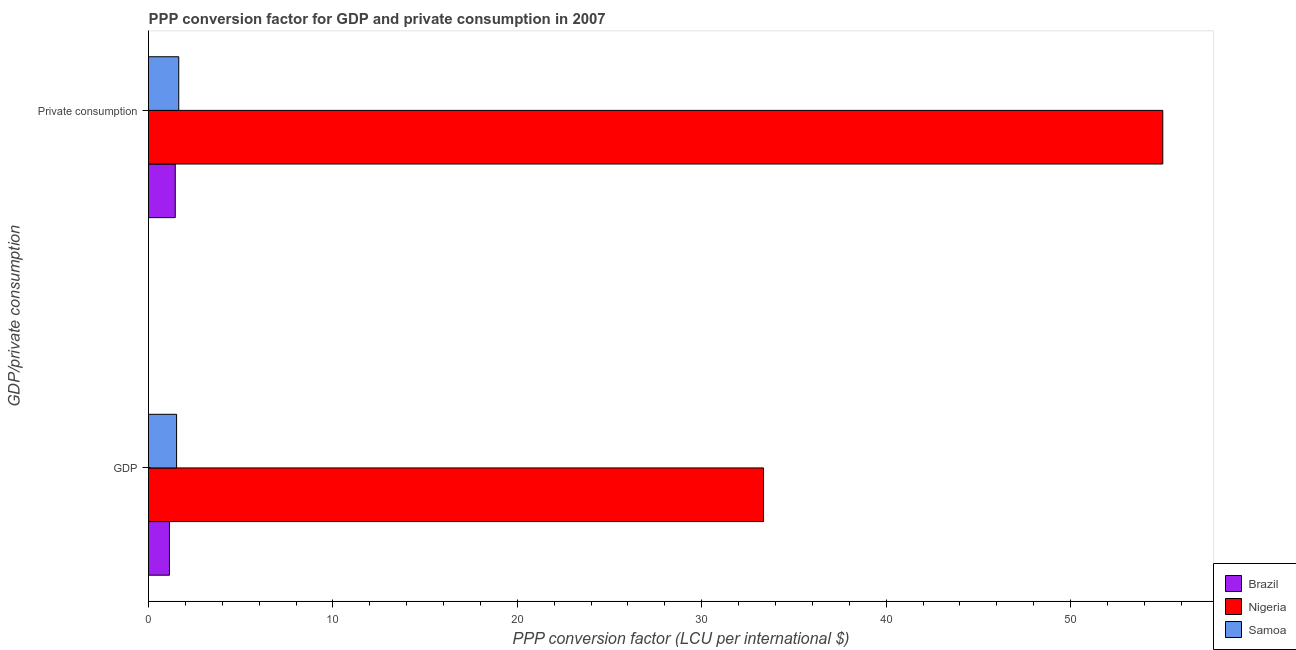How many groups of bars are there?
Keep it short and to the point. 2. Are the number of bars per tick equal to the number of legend labels?
Make the answer very short. Yes. Are the number of bars on each tick of the Y-axis equal?
Offer a very short reply. Yes. How many bars are there on the 2nd tick from the top?
Give a very brief answer. 3. How many bars are there on the 1st tick from the bottom?
Offer a terse response. 3. What is the label of the 1st group of bars from the top?
Ensure brevity in your answer.   Private consumption. What is the ppp conversion factor for gdp in Samoa?
Your response must be concise. 1.52. Across all countries, what is the maximum ppp conversion factor for private consumption?
Your response must be concise. 55. Across all countries, what is the minimum ppp conversion factor for private consumption?
Offer a terse response. 1.45. In which country was the ppp conversion factor for private consumption maximum?
Your answer should be compact. Nigeria. In which country was the ppp conversion factor for gdp minimum?
Offer a terse response. Brazil. What is the total ppp conversion factor for private consumption in the graph?
Your response must be concise. 58.09. What is the difference between the ppp conversion factor for private consumption in Samoa and that in Nigeria?
Give a very brief answer. -53.36. What is the difference between the ppp conversion factor for private consumption in Nigeria and the ppp conversion factor for gdp in Brazil?
Keep it short and to the point. 53.87. What is the average ppp conversion factor for private consumption per country?
Make the answer very short. 19.36. What is the difference between the ppp conversion factor for gdp and ppp conversion factor for private consumption in Brazil?
Provide a short and direct response. -0.31. What is the ratio of the ppp conversion factor for private consumption in Brazil to that in Nigeria?
Your answer should be compact. 0.03. Is the ppp conversion factor for gdp in Samoa less than that in Brazil?
Your response must be concise. No. What does the 3rd bar from the top in  Private consumption represents?
Offer a terse response. Brazil. What does the 2nd bar from the bottom in GDP represents?
Ensure brevity in your answer.  Nigeria. How many countries are there in the graph?
Make the answer very short. 3. How many legend labels are there?
Your answer should be very brief. 3. How are the legend labels stacked?
Offer a very short reply. Vertical. What is the title of the graph?
Offer a very short reply. PPP conversion factor for GDP and private consumption in 2007. What is the label or title of the X-axis?
Give a very brief answer. PPP conversion factor (LCU per international $). What is the label or title of the Y-axis?
Offer a very short reply. GDP/private consumption. What is the PPP conversion factor (LCU per international $) in Brazil in GDP?
Provide a short and direct response. 1.14. What is the PPP conversion factor (LCU per international $) of Nigeria in GDP?
Ensure brevity in your answer.  33.35. What is the PPP conversion factor (LCU per international $) in Samoa in GDP?
Ensure brevity in your answer.  1.52. What is the PPP conversion factor (LCU per international $) of Brazil in  Private consumption?
Your response must be concise. 1.45. What is the PPP conversion factor (LCU per international $) of Nigeria in  Private consumption?
Your response must be concise. 55. What is the PPP conversion factor (LCU per international $) of Samoa in  Private consumption?
Ensure brevity in your answer.  1.64. Across all GDP/private consumption, what is the maximum PPP conversion factor (LCU per international $) in Brazil?
Make the answer very short. 1.45. Across all GDP/private consumption, what is the maximum PPP conversion factor (LCU per international $) of Nigeria?
Provide a succinct answer. 55. Across all GDP/private consumption, what is the maximum PPP conversion factor (LCU per international $) in Samoa?
Your answer should be compact. 1.64. Across all GDP/private consumption, what is the minimum PPP conversion factor (LCU per international $) in Brazil?
Offer a terse response. 1.14. Across all GDP/private consumption, what is the minimum PPP conversion factor (LCU per international $) in Nigeria?
Offer a very short reply. 33.35. Across all GDP/private consumption, what is the minimum PPP conversion factor (LCU per international $) of Samoa?
Offer a terse response. 1.52. What is the total PPP conversion factor (LCU per international $) in Brazil in the graph?
Your answer should be very brief. 2.59. What is the total PPP conversion factor (LCU per international $) of Nigeria in the graph?
Your answer should be very brief. 88.35. What is the total PPP conversion factor (LCU per international $) of Samoa in the graph?
Ensure brevity in your answer.  3.16. What is the difference between the PPP conversion factor (LCU per international $) of Brazil in GDP and that in  Private consumption?
Provide a succinct answer. -0.31. What is the difference between the PPP conversion factor (LCU per international $) in Nigeria in GDP and that in  Private consumption?
Give a very brief answer. -21.65. What is the difference between the PPP conversion factor (LCU per international $) of Samoa in GDP and that in  Private consumption?
Your response must be concise. -0.12. What is the difference between the PPP conversion factor (LCU per international $) of Brazil in GDP and the PPP conversion factor (LCU per international $) of Nigeria in  Private consumption?
Your answer should be compact. -53.87. What is the difference between the PPP conversion factor (LCU per international $) in Brazil in GDP and the PPP conversion factor (LCU per international $) in Samoa in  Private consumption?
Offer a very short reply. -0.5. What is the difference between the PPP conversion factor (LCU per international $) of Nigeria in GDP and the PPP conversion factor (LCU per international $) of Samoa in  Private consumption?
Offer a terse response. 31.71. What is the average PPP conversion factor (LCU per international $) of Brazil per GDP/private consumption?
Keep it short and to the point. 1.29. What is the average PPP conversion factor (LCU per international $) of Nigeria per GDP/private consumption?
Your response must be concise. 44.18. What is the average PPP conversion factor (LCU per international $) of Samoa per GDP/private consumption?
Offer a terse response. 1.58. What is the difference between the PPP conversion factor (LCU per international $) in Brazil and PPP conversion factor (LCU per international $) in Nigeria in GDP?
Your answer should be compact. -32.21. What is the difference between the PPP conversion factor (LCU per international $) of Brazil and PPP conversion factor (LCU per international $) of Samoa in GDP?
Offer a terse response. -0.39. What is the difference between the PPP conversion factor (LCU per international $) in Nigeria and PPP conversion factor (LCU per international $) in Samoa in GDP?
Provide a succinct answer. 31.83. What is the difference between the PPP conversion factor (LCU per international $) in Brazil and PPP conversion factor (LCU per international $) in Nigeria in  Private consumption?
Give a very brief answer. -53.55. What is the difference between the PPP conversion factor (LCU per international $) of Brazil and PPP conversion factor (LCU per international $) of Samoa in  Private consumption?
Make the answer very short. -0.19. What is the difference between the PPP conversion factor (LCU per international $) in Nigeria and PPP conversion factor (LCU per international $) in Samoa in  Private consumption?
Keep it short and to the point. 53.36. What is the ratio of the PPP conversion factor (LCU per international $) of Brazil in GDP to that in  Private consumption?
Keep it short and to the point. 0.78. What is the ratio of the PPP conversion factor (LCU per international $) in Nigeria in GDP to that in  Private consumption?
Your response must be concise. 0.61. What is the ratio of the PPP conversion factor (LCU per international $) in Samoa in GDP to that in  Private consumption?
Offer a terse response. 0.93. What is the difference between the highest and the second highest PPP conversion factor (LCU per international $) in Brazil?
Provide a short and direct response. 0.31. What is the difference between the highest and the second highest PPP conversion factor (LCU per international $) in Nigeria?
Provide a short and direct response. 21.65. What is the difference between the highest and the second highest PPP conversion factor (LCU per international $) of Samoa?
Your answer should be very brief. 0.12. What is the difference between the highest and the lowest PPP conversion factor (LCU per international $) of Brazil?
Provide a short and direct response. 0.31. What is the difference between the highest and the lowest PPP conversion factor (LCU per international $) of Nigeria?
Give a very brief answer. 21.65. What is the difference between the highest and the lowest PPP conversion factor (LCU per international $) in Samoa?
Keep it short and to the point. 0.12. 